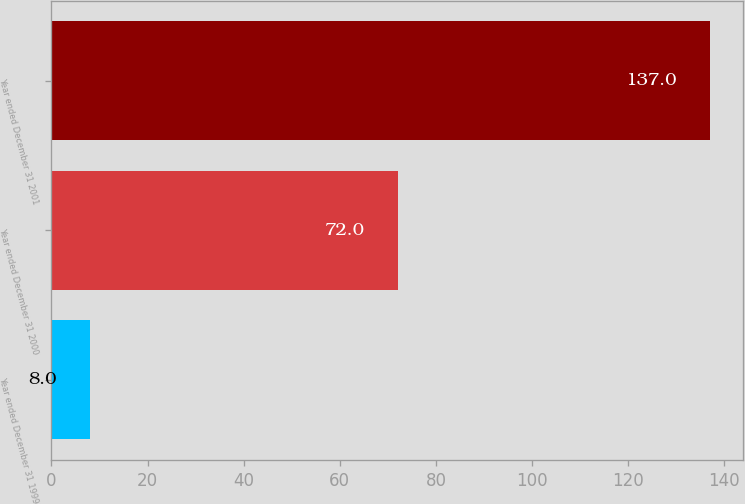Convert chart to OTSL. <chart><loc_0><loc_0><loc_500><loc_500><bar_chart><fcel>Year ended December 31 1999<fcel>Year ended December 31 2000<fcel>Year ended December 31 2001<nl><fcel>8<fcel>72<fcel>137<nl></chart> 